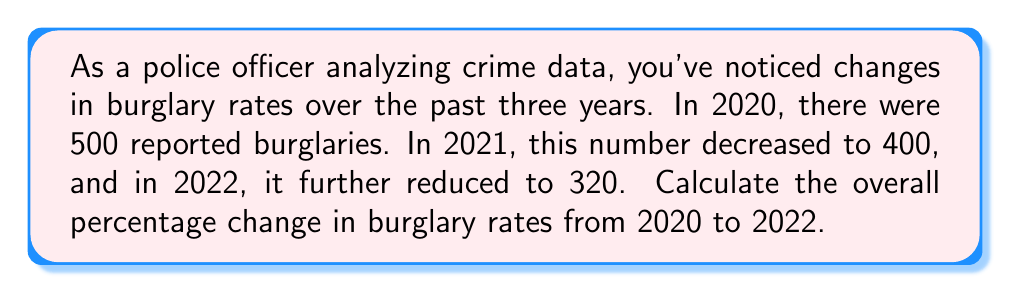Can you answer this question? To calculate the overall percentage change in burglary rates from 2020 to 2022, we'll use the following formula:

$$ \text{Percentage Change} = \frac{\text{Final Value} - \text{Initial Value}}{\text{Initial Value}} \times 100\% $$

Given:
- Initial value (2020): 500 burglaries
- Final value (2022): 320 burglaries

Let's substitute these values into the formula:

$$ \text{Percentage Change} = \frac{320 - 500}{500} \times 100\% $$

$$ = \frac{-180}{500} \times 100\% $$

$$ = -0.36 \times 100\% $$

$$ = -36\% $$

The negative sign indicates a decrease in the burglary rate.

To verify this result, we can calculate the percentage of the original value that remains:
$$ \frac{320}{500} = 0.64 = 64\% $$

This means that the 2022 value is 64% of the 2020 value, confirming a 36% decrease.
Answer: The overall percentage change in burglary rates from 2020 to 2022 is a decrease of 36%. 